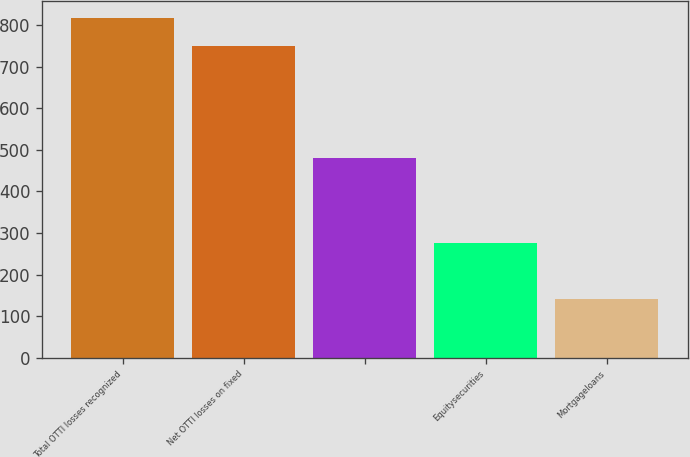<chart> <loc_0><loc_0><loc_500><loc_500><bar_chart><fcel>Total OTTI losses recognized<fcel>Net OTTI losses on fixed<fcel>Unnamed: 2<fcel>Equitysecurities<fcel>Mortgageloans<nl><fcel>817.2<fcel>749.6<fcel>479.2<fcel>276.4<fcel>141.2<nl></chart> 